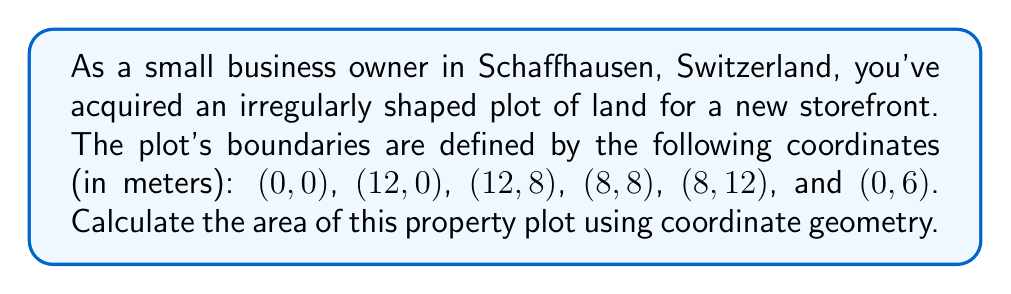Can you answer this question? To calculate the area of this irregular polygon, we can use the Shoelace formula (also known as the surveyor's formula). This method involves splitting the polygon into triangles and summing their areas.

The formula is:

$$ A = \frac{1}{2}\left|\sum_{i=1}^{n-1} (x_i y_{i+1} - x_{i+1} y_i) + (x_n y_1 - x_1 y_n)\right| $$

Where $(x_i, y_i)$ are the coordinates of the $i$-th vertex, and $n$ is the number of vertices.

Let's apply this formula to our coordinates:

1. List the coordinates in order:
   (0,0), (12,0), (12,8), (8,8), (8,12), (0,6)

2. Apply the formula:

   $A = \frac{1}{2}|(0 \cdot 0 - 12 \cdot 0) + (12 \cdot 8 - 12 \cdot 0) + (12 \cdot 8 - 8 \cdot 8) + (8 \cdot 12 - 8 \cdot 8) + (8 \cdot 6 - 0 \cdot 12) + (0 \cdot 0 - 0 \cdot 6)|$

3. Simplify:
   $A = \frac{1}{2}|0 + 96 + 32 + 32 + 48 + 0|$

4. Calculate:
   $A = \frac{1}{2} \cdot 208 = 104$

Therefore, the area of the property plot is 104 square meters.

[asy]
unitsize(5mm);
draw((0,0)--(12,0)--(12,8)--(8,8)--(8,12)--(0,6)--cycle);
label("(0,0)", (0,0), SW);
label("(12,0)", (12,0), SE);
label("(12,8)", (12,8), NE);
label("(8,8)", (8,8), E);
label("(8,12)", (8,12), N);
label("(0,6)", (0,6), W);
[/asy]
Answer: The area of the irregular-shaped property plot is 104 square meters. 